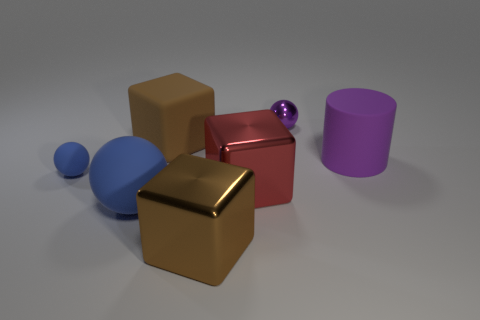Subtract all blue spheres. How many spheres are left? 1 Subtract all red cylinders. How many blue balls are left? 2 Subtract 1 blocks. How many blocks are left? 2 Add 2 big rubber blocks. How many objects exist? 9 Subtract all blue spheres. How many spheres are left? 1 Subtract all large blocks. Subtract all small blue objects. How many objects are left? 3 Add 7 big rubber balls. How many big rubber balls are left? 8 Add 4 large matte spheres. How many large matte spheres exist? 5 Subtract 0 brown balls. How many objects are left? 7 Subtract all cylinders. How many objects are left? 6 